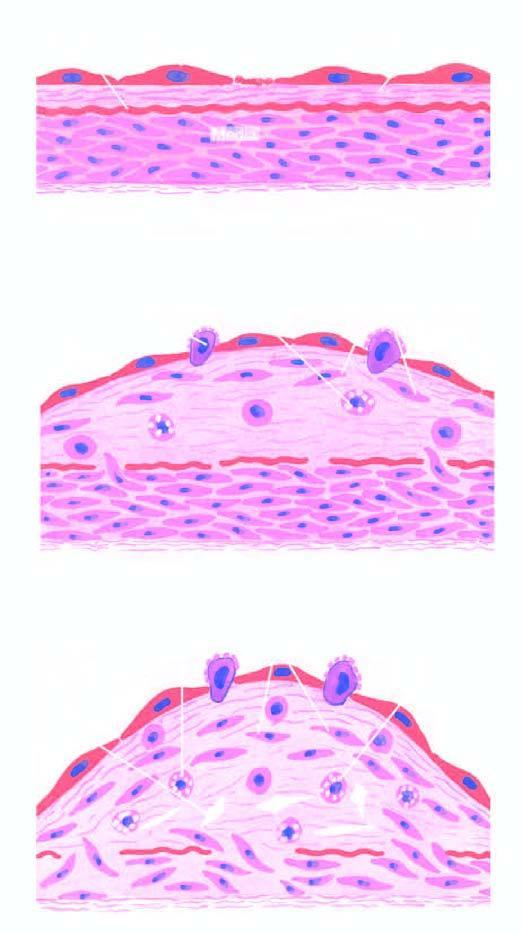what is diagrammatic representation of pathogenesis of atherosclerosis explained by?
Answer the question using a single word or phrase. 'reaction-to-injury 'hypothesis 